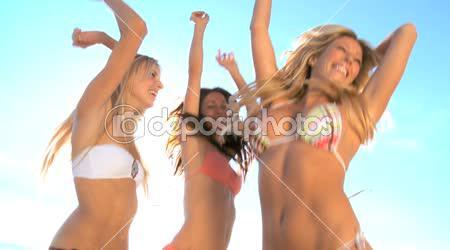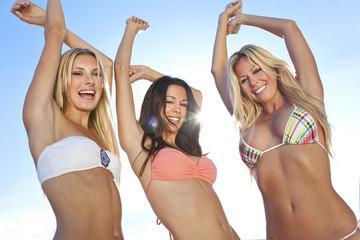The first image is the image on the left, the second image is the image on the right. Considering the images on both sides, is "In one image, the backsides of three women dressed in bikinis are visible" valid? Answer yes or no. No. The first image is the image on the left, the second image is the image on the right. For the images shown, is this caption "An image shows three rear-facing models, standing in front of water." true? Answer yes or no. No. 